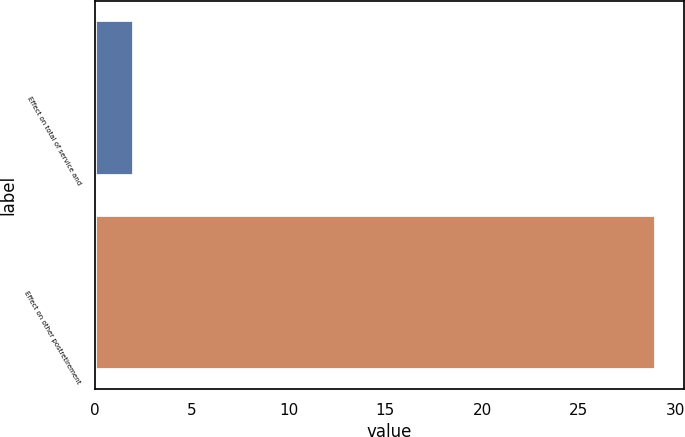Convert chart to OTSL. <chart><loc_0><loc_0><loc_500><loc_500><bar_chart><fcel>Effect on total of service and<fcel>Effect on other postretirement<nl><fcel>2<fcel>29<nl></chart> 